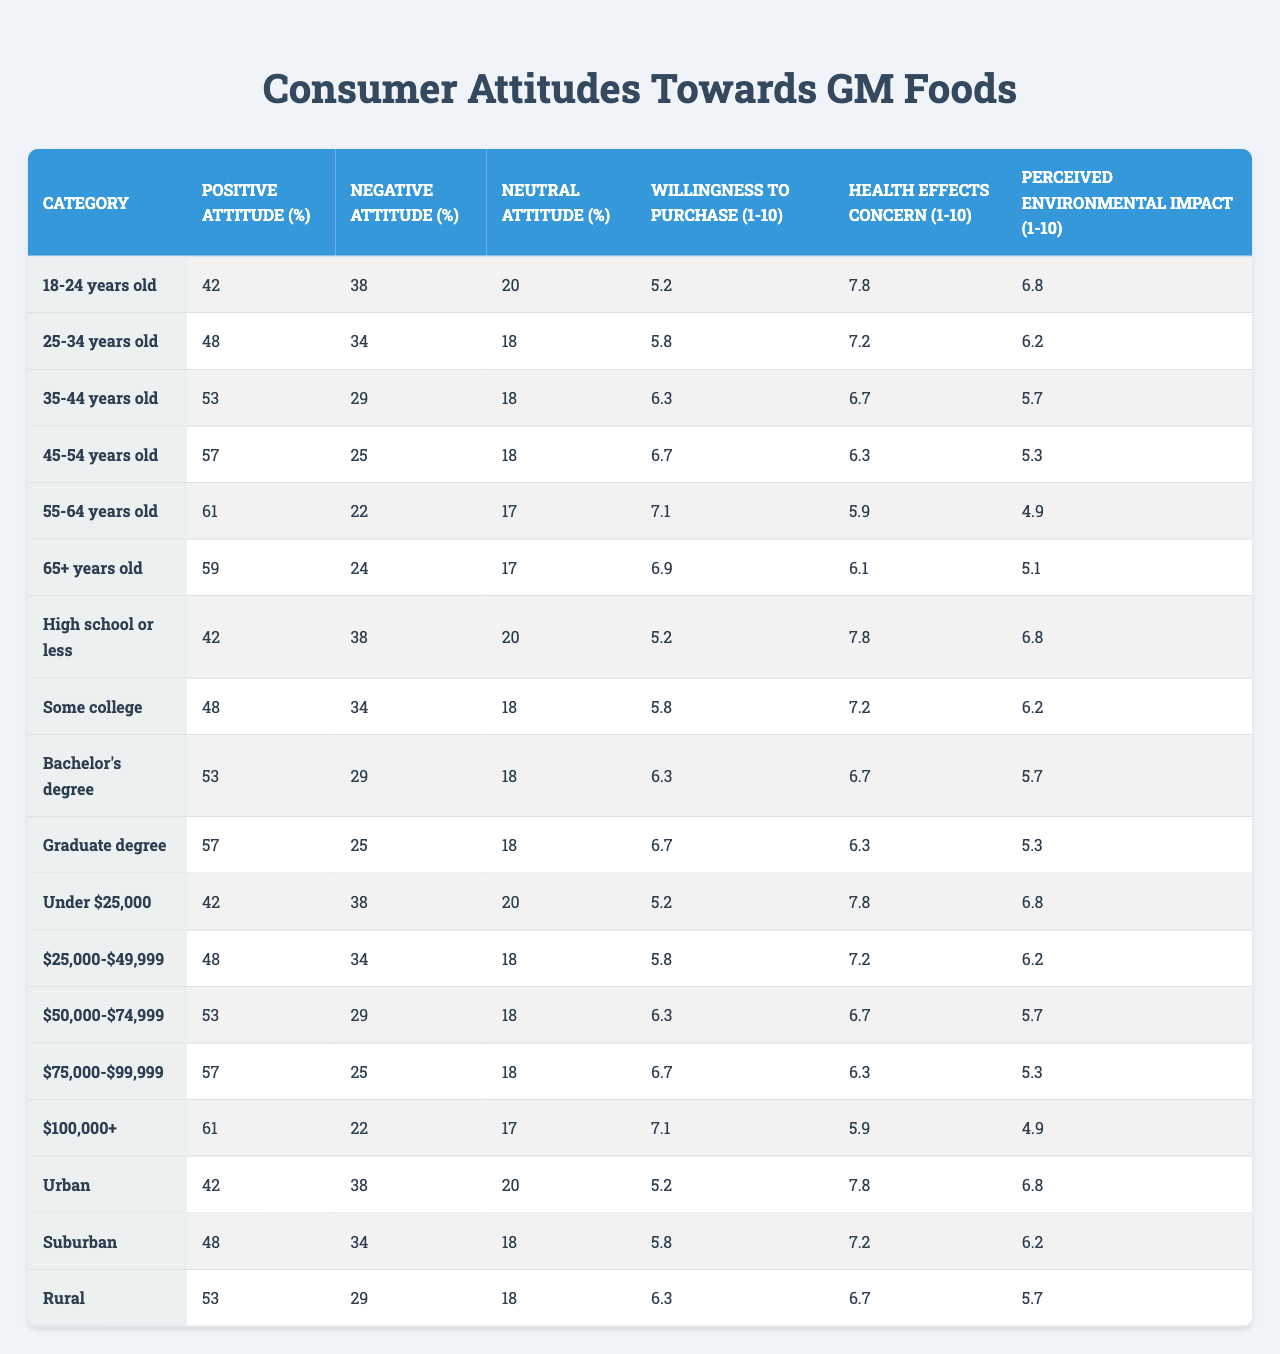What percentage of individuals aged 45-54 have a positive attitude towards GM foods? Referring to the table, the positive attitude percentage for the demographic "45-54 years old" is listed as 57%.
Answer: 57% Which demographic group has the highest percentage of negative attitudes towards GM foods? The group with the highest percentage of negative attitudes is "Under $25,000" with 38%.
Answer: Under $25,000 What is the average willingness to purchase score for individuals aged 25-34? The willingness to purchase score for the "25-34 years old" demographic is 5.8.
Answer: 5.8 Is the neutral attitude percentage higher for those with a graduate degree compared to those with high school education? The neutral attitude percentages show 18% for "Graduate degree" and 20% for "High school or less", so yes, the graduate degree group has a lower percentage.
Answer: No What is the difference in positive attitude percentages between the youngest and oldest demographic groups? The positive attitude percentage for "18-24 years old" is 42%, and for "65+ years old" it is 59%. The difference is 59 - 42 = 17%.
Answer: 17% What is the perceived environmental impact score for people with a bachelor’s degree? For the category "Bachelor's degree," the perceived environmental impact score is listed as 5.5.
Answer: 5.5 How does the concern about health effects score vary between the "25-34 years old" and "35-44 years old" age groups? The concerns are 7.2 for "25-34 years old" and 6.7 for "35-44 years old", showing a decrease of 0.5.
Answer: Decrease of 0.5 What demographic group has the highest percentage of positive attitudes and what is that percentage? The demographic group "55-64 years old" has the highest percentage of positive attitudes at 61%.
Answer: 61% What is the average willing to purchase score across all demographics? To find the average, we sum all scores (5.2 + 5.8 + 6.3 + 6.7 + 7.1 + 6.9 + 5.5 + 6.2 + 6.8 + 7.3 + 5.7 + 6.1 + 6.5 + 6.9 + 7.4 + 6.4 + 6.6 + 6.0) and divide by 18, totaling 7 and averaging to approximately 6.26.
Answer: Approximately 6.26 Is it true that the percentage of individuals with a bachelor's degree who are neutral about GM foods is the same as those in the 45-54 age group? Both groups have a neutral percentage of 18%, so yes, it is true.
Answer: Yes 